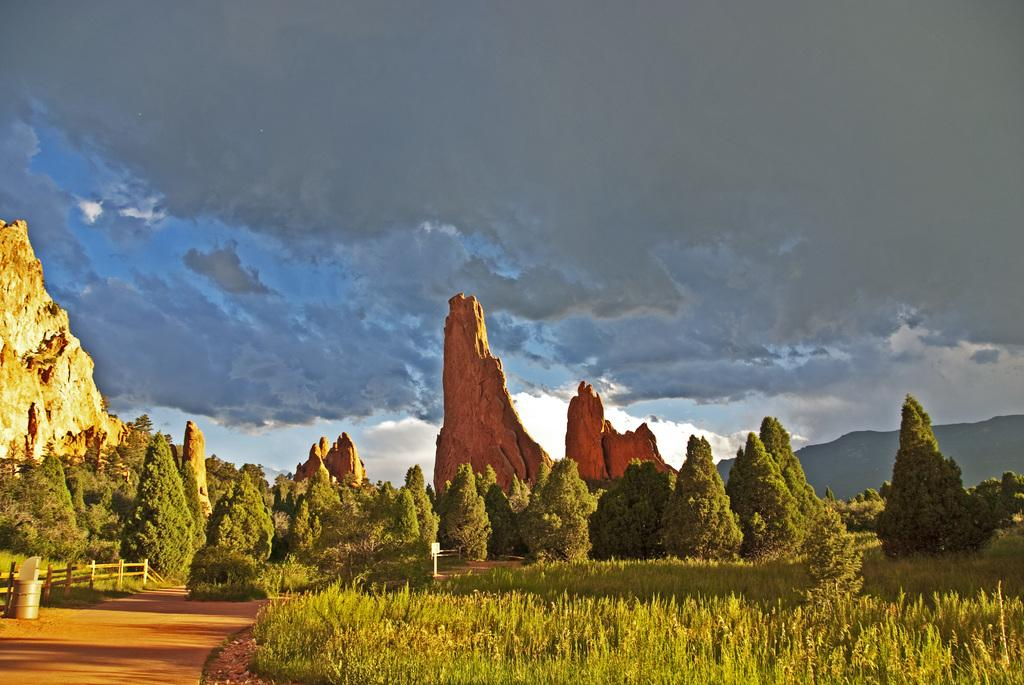What type of vegetation is present on the ground in the image? There is grass on the ground in the image. What other natural elements can be seen in the image? There are trees and mountains in the image. What is the condition of the sky in the image? The sky is cloudy in the image. How many worms can be seen crawling through the hole in the image? There are no worms or holes present in the image. What is the value of the quarter lying on the grass in the image? There is no quarter present in the image. 